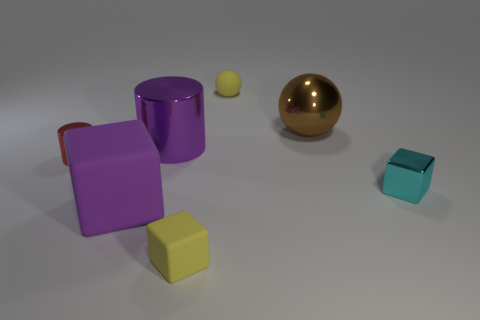Add 1 small cyan balls. How many objects exist? 8 Subtract all cylinders. How many objects are left? 5 Subtract 0 red spheres. How many objects are left? 7 Subtract all purple objects. Subtract all yellow spheres. How many objects are left? 4 Add 4 tiny cylinders. How many tiny cylinders are left? 5 Add 1 large red metallic blocks. How many large red metallic blocks exist? 1 